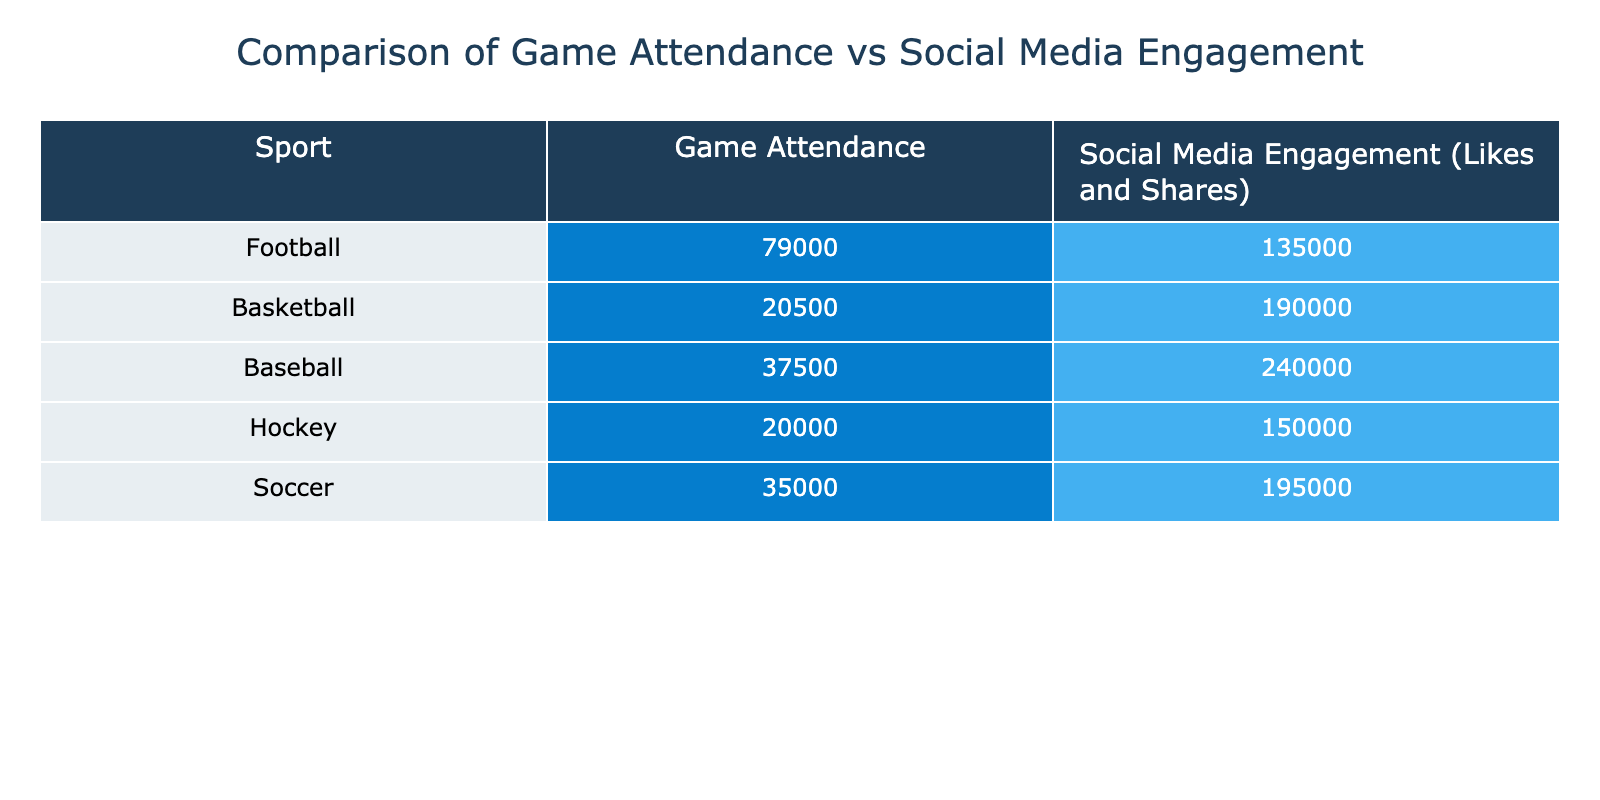What is the game attendance for the Dallas Cowboys? The table shows that the game attendance for the Dallas Cowboys is listed as 80000.
Answer: 80000 What is the average social media engagement for NHL teams? To find the average social media engagement for NHL teams, we look at the Chicago Blackhawks with 160000 and the Pittsburgh Penguins with 140000. Adding these gives 300000, and dividing by 2 results in an average of 150000.
Answer: 150000 Does the New York Yankees have higher social media engagement than the Green Bay Packers? The social media engagement for the New York Yankees is 250000 and for the Green Bay Packers is 120000. Since 250000 is greater than 120000, the answer is yes.
Answer: Yes Which sport has the highest average game attendance? The game attendance data shows the Dallas Cowboys with 80000, Green Bay Packers with 78000, Los Angeles Lakers with 19000, Chicago Bulls with 22000, New York Yankees with 40000, San Francisco Giants with 35000, Chicago Blackhawks with 22000, Pittsburgh Penguins with 18000, LA Galaxy with 25000, and Atlanta United with 45000. The highest number is 80000 from the Dallas Cowboys.
Answer: 80000 What is the total social media engagement for teams in baseball? The social media engagement for the New York Yankees is 250000 and for the San Francisco Giants is 230000. Adding these numbers gives 480000 total social media engagement for baseball teams.
Answer: 480000 Is the average game attendance for soccer teams lower than that of basketball teams? The average game attendance for soccer teams (LA Galaxy: 25000, Atlanta United: 45000) is calculated as follows: (25000 + 45000) / 2 = 35000. For basketball teams (Los Angeles Lakers: 19000, Chicago Bulls: 22000), the average is (19000 + 22000) / 2 = 20500. Comparing the two, 35000 is higher than 20500, so the answer is no.
Answer: No Which team has the lowest social media engagement? The table shows that the team with the lowest social media engagement is the Pittsburgh Penguins, with 140000.
Answer: 140000 What is the difference in social media engagement between the Atlanta United and the Chicago Bulls? The social media engagement for Atlanta United is 300000, and for Chicago Bulls, it is 180000. The difference is calculated as 300000 - 180000 = 120000.
Answer: 120000 Which sport has the highest overall social media engagement? To determine this, we calculate the total social media engagement for each sport. Football (Dallas Cowboys 150000 + Green Bay Packers 120000 = 270000), Basketball (Los Angeles Lakers 200000 + Chicago Bulls 180000 = 380000), Baseball (New York Yankees 250000 + San Francisco Giants 230000 = 480000), Hockey (Chicago Blackhawks 160000 + Pittsburgh Penguins 140000 = 300000), and Soccer (LA Galaxy 90000 + Atlanta United 300000 = 390000). The highest total is for Baseball at 480000.
Answer: Baseball 